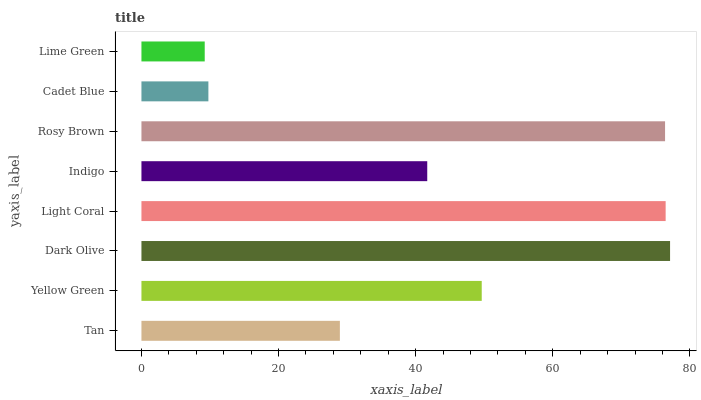Is Lime Green the minimum?
Answer yes or no. Yes. Is Dark Olive the maximum?
Answer yes or no. Yes. Is Yellow Green the minimum?
Answer yes or no. No. Is Yellow Green the maximum?
Answer yes or no. No. Is Yellow Green greater than Tan?
Answer yes or no. Yes. Is Tan less than Yellow Green?
Answer yes or no. Yes. Is Tan greater than Yellow Green?
Answer yes or no. No. Is Yellow Green less than Tan?
Answer yes or no. No. Is Yellow Green the high median?
Answer yes or no. Yes. Is Indigo the low median?
Answer yes or no. Yes. Is Dark Olive the high median?
Answer yes or no. No. Is Rosy Brown the low median?
Answer yes or no. No. 